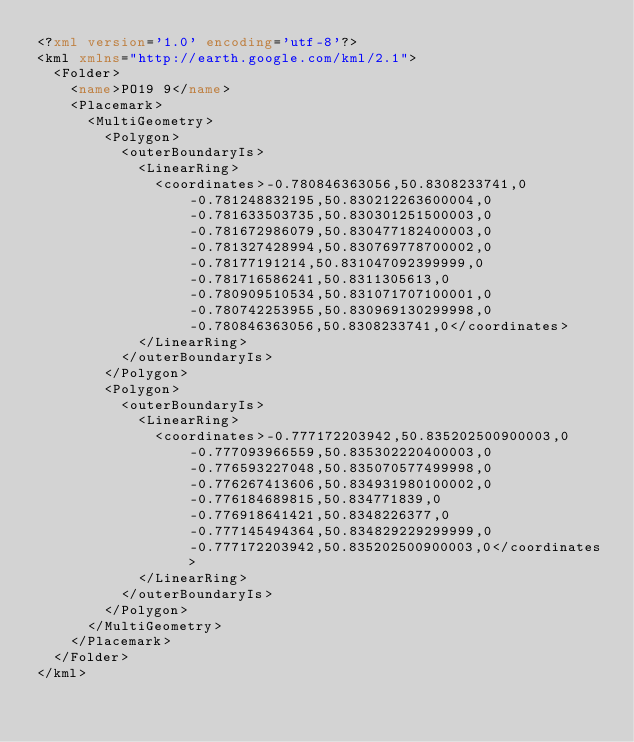Convert code to text. <code><loc_0><loc_0><loc_500><loc_500><_XML_><?xml version='1.0' encoding='utf-8'?>
<kml xmlns="http://earth.google.com/kml/2.1">
  <Folder>
    <name>PO19 9</name>
    <Placemark>
      <MultiGeometry>
        <Polygon>
          <outerBoundaryIs>
            <LinearRing>
              <coordinates>-0.780846363056,50.8308233741,0 -0.781248832195,50.830212263600004,0 -0.781633503735,50.830301251500003,0 -0.781672986079,50.830477182400003,0 -0.781327428994,50.830769778700002,0 -0.78177191214,50.831047092399999,0 -0.781716586241,50.8311305613,0 -0.780909510534,50.831071707100001,0 -0.780742253955,50.830969130299998,0 -0.780846363056,50.8308233741,0</coordinates>
            </LinearRing>
          </outerBoundaryIs>
        </Polygon>
        <Polygon>
          <outerBoundaryIs>
            <LinearRing>
              <coordinates>-0.777172203942,50.835202500900003,0 -0.777093966559,50.835302220400003,0 -0.776593227048,50.835070577499998,0 -0.776267413606,50.834931980100002,0 -0.776184689815,50.834771839,0 -0.776918641421,50.8348226377,0 -0.777145494364,50.834829229299999,0 -0.777172203942,50.835202500900003,0</coordinates>
            </LinearRing>
          </outerBoundaryIs>
        </Polygon>
      </MultiGeometry>
    </Placemark>
  </Folder>
</kml>
</code> 